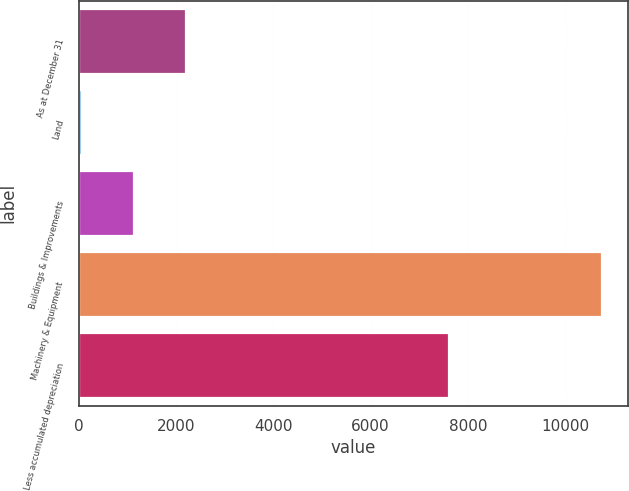<chart> <loc_0><loc_0><loc_500><loc_500><bar_chart><fcel>As at December 31<fcel>Land<fcel>Buildings & Improvements<fcel>Machinery & Equipment<fcel>Less accumulated depreciation<nl><fcel>2202.8<fcel>66<fcel>1134.4<fcel>10750<fcel>7604<nl></chart> 